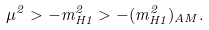<formula> <loc_0><loc_0><loc_500><loc_500>\mu ^ { 2 } > - m _ { H 1 } ^ { 2 } > - ( m _ { H 1 } ^ { 2 } ) _ { A M } .</formula> 